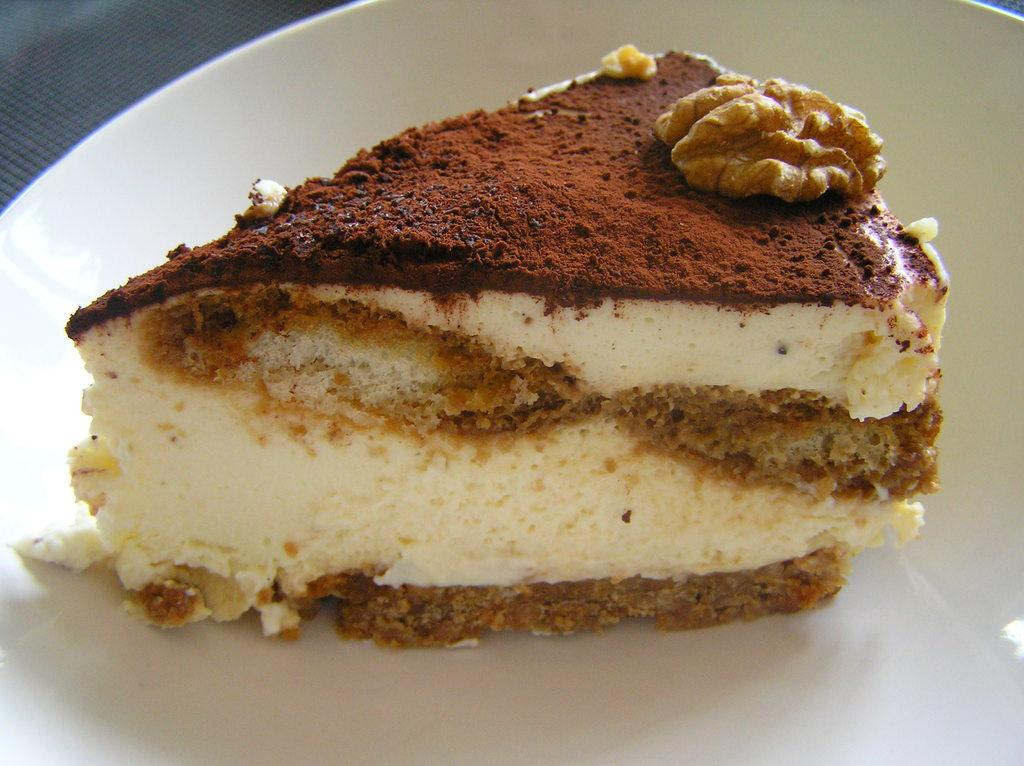What is the main subject of the image? There is a cake on a plate in the image. Can you describe the cake in the image? The cake is on a plate, but no specific details about its appearance or flavor are provided. Is there anything else visible in the image besides the cake? The facts provided do not mention any other objects or elements in the image. What temperature does the faucet need to be set at to properly wash the cake plate in the image? There is no faucet present in the image, so it is not possible to determine the appropriate temperature for washing the cake plate. 